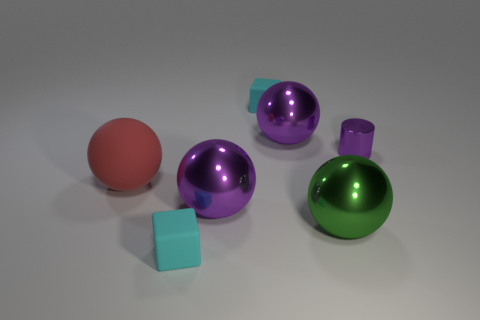There is a tiny object that is behind the large green shiny thing and to the left of the tiny purple cylinder; what shape is it?
Offer a very short reply. Cube. What number of other small objects have the same shape as the red matte object?
Provide a short and direct response. 0. There is a cylinder that is made of the same material as the large green object; what size is it?
Your answer should be compact. Small. What number of matte cubes are the same size as the purple cylinder?
Ensure brevity in your answer.  2. What color is the big metal object that is behind the big purple metallic ball that is in front of the red ball?
Ensure brevity in your answer.  Purple. Is there a large metal ball of the same color as the tiny shiny cylinder?
Give a very brief answer. Yes. What color is the rubber sphere that is the same size as the green shiny thing?
Your response must be concise. Red. Are the purple thing in front of the red matte sphere and the big green thing made of the same material?
Your answer should be very brief. Yes. There is a rubber cube on the right side of the small cyan matte block in front of the tiny metal cylinder; is there a green metal ball behind it?
Offer a terse response. No. There is a purple shiny thing right of the big green metal ball; is it the same shape as the large green object?
Offer a very short reply. No. 